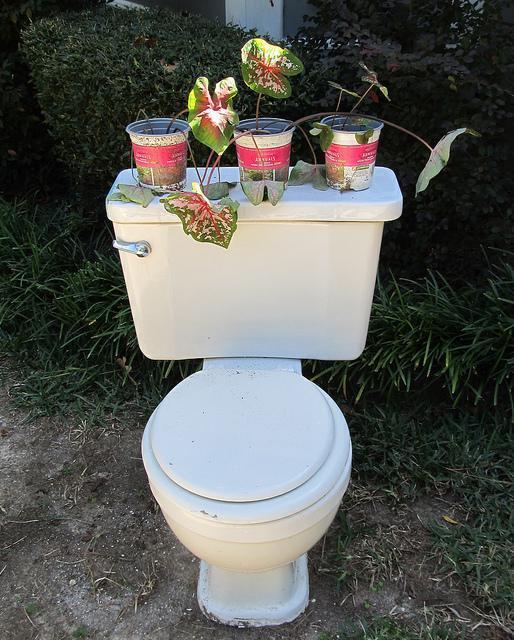How many potted plants do you see?
Give a very brief answer. 3. How many potted plants are in the photo?
Give a very brief answer. 3. How many toilets can be seen?
Give a very brief answer. 1. 